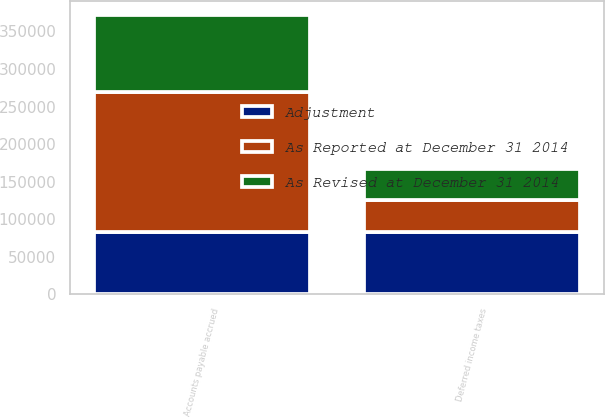Convert chart to OTSL. <chart><loc_0><loc_0><loc_500><loc_500><stacked_bar_chart><ecel><fcel>Deferred income taxes<fcel>Accounts payable accrued<nl><fcel>As Revised at December 31 2014<fcel>41716<fcel>102443<nl><fcel>Adjustment<fcel>83432<fcel>83432<nl><fcel>As Reported at December 31 2014<fcel>41716<fcel>185875<nl></chart> 